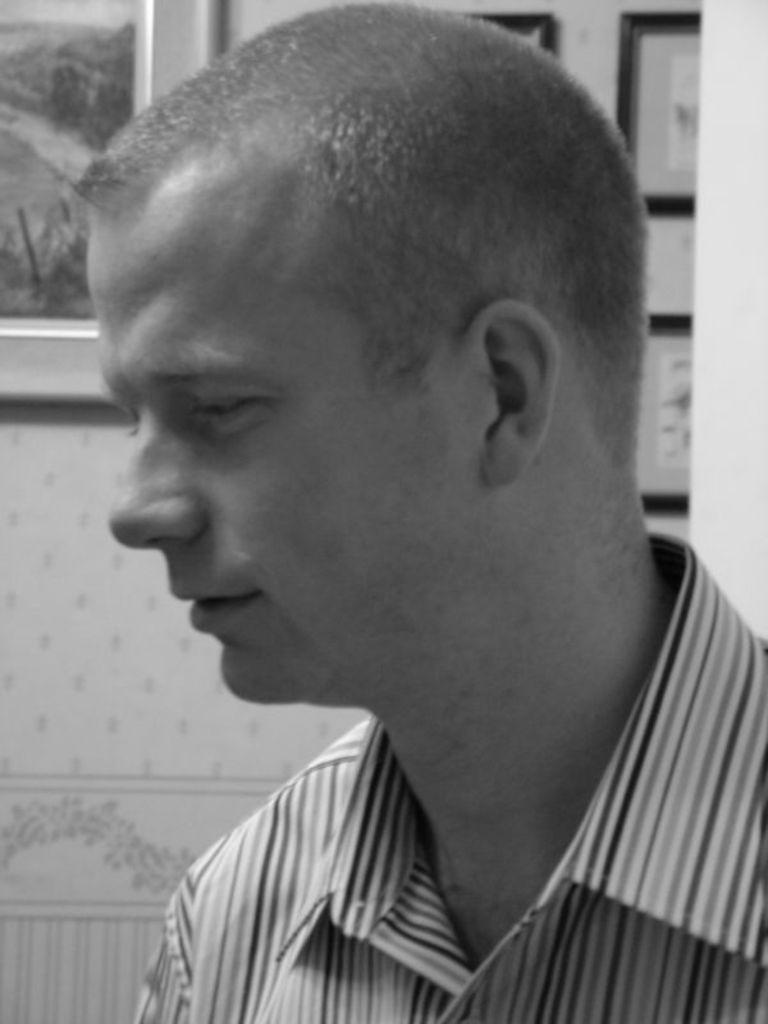Please provide a concise description of this image. This image is a black and white image. This image is taken indoors. In the background there is a wall with a few picture frames on it. On the right side of the image there is a man. 